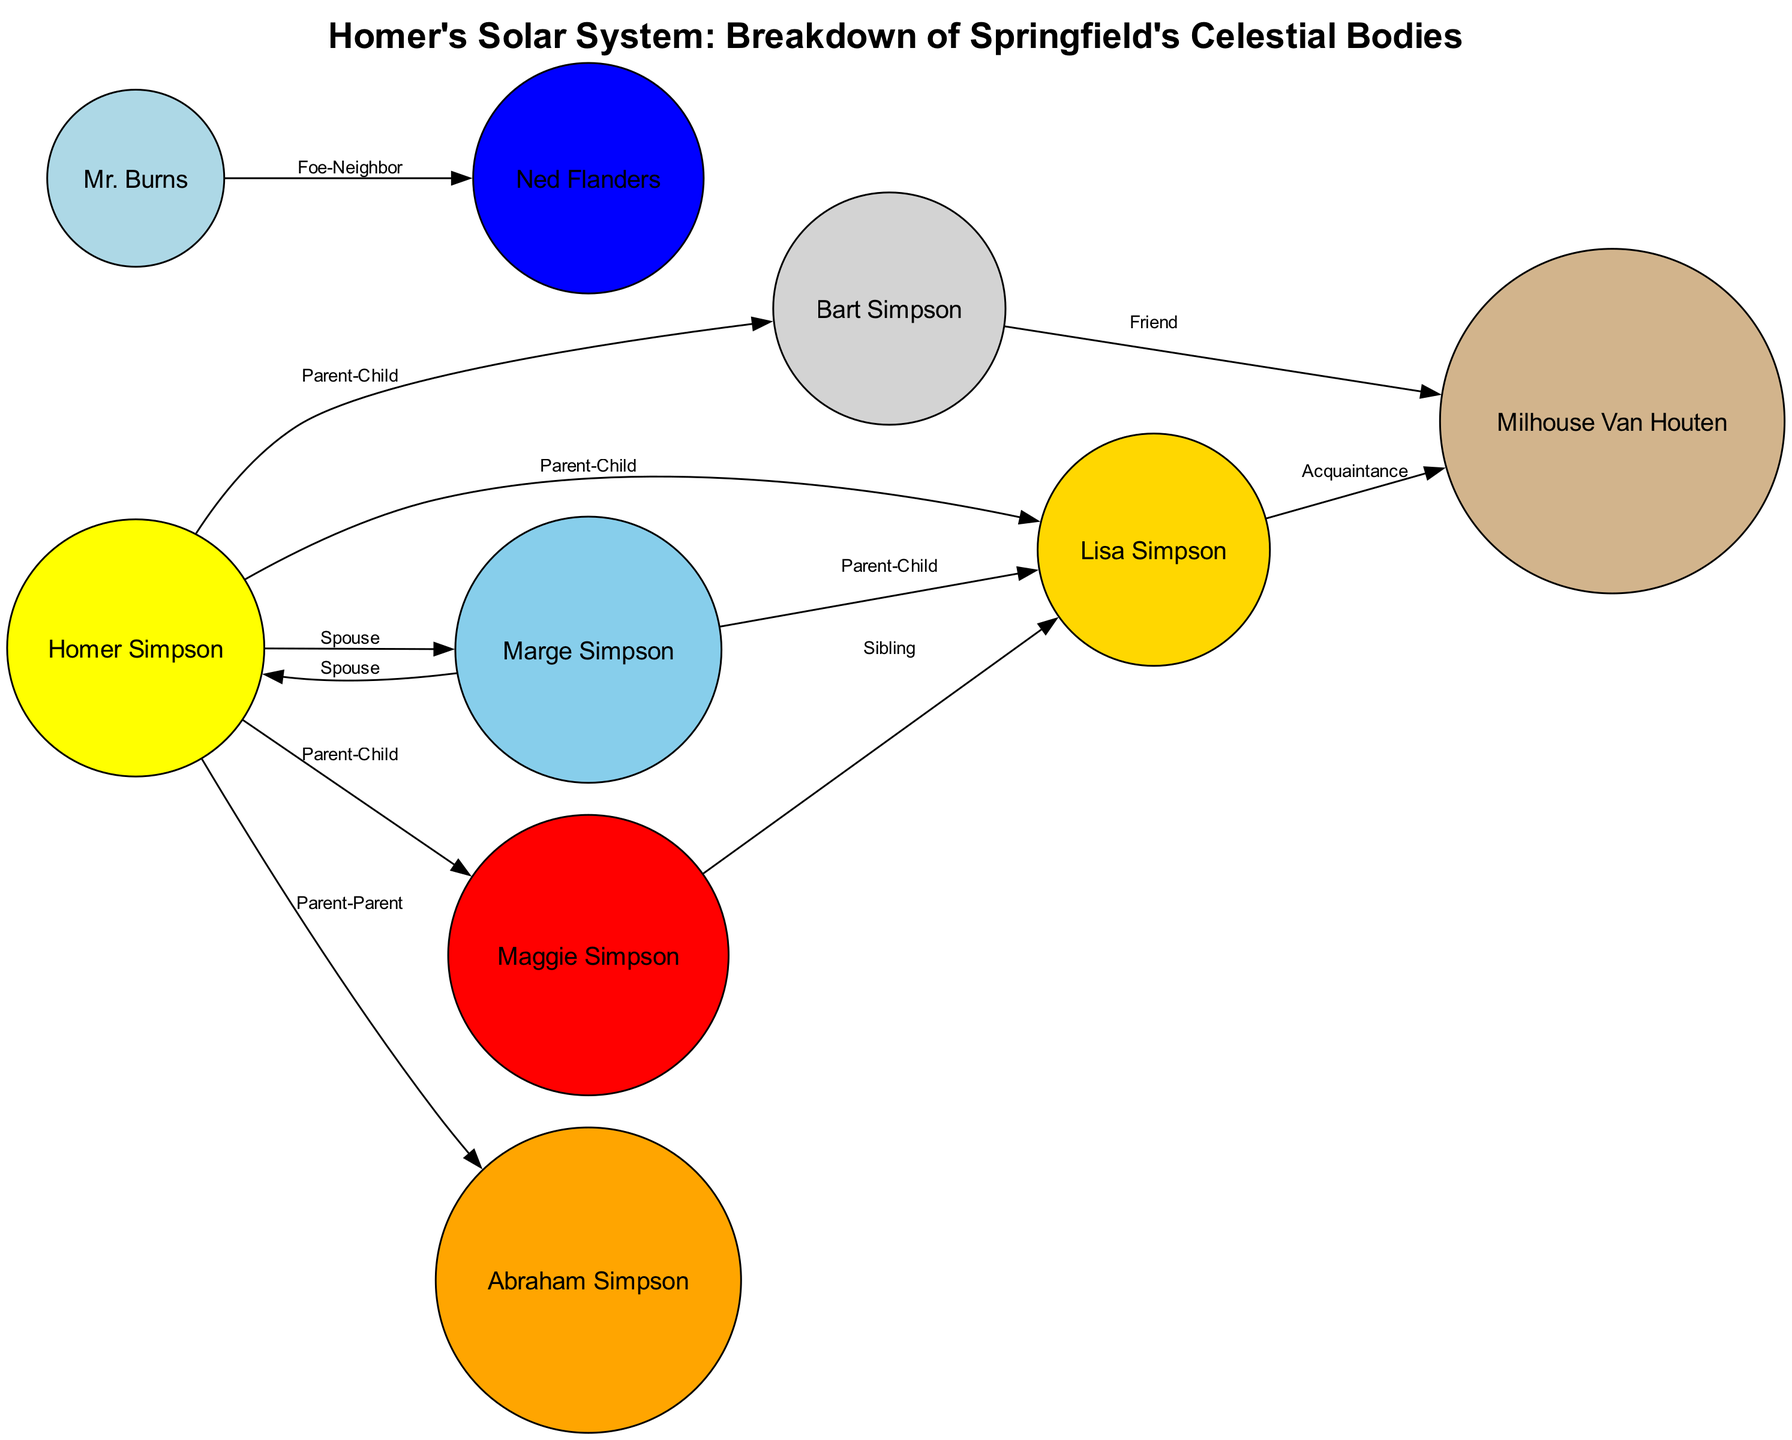What is the central star in the diagram? The diagram identifies "Homer Simpson" as the central star, which represents the heart and soul of 'The Simpsons'.
Answer: Homer Simpson Which character is represented as the planet Mars? In the diagram, Mars is represented by "Maggie Simpson," described as a small but powerful entity.
Answer: Maggie Simpson How many nodes are used to represent planets in this solar system? The diagram includes 8 nodes, comprising 7 planets and 1 star (Homer Simpson), to represent the characters.
Answer: 7 What type of relationship exists between Homer Simpson and Earth? The relationship between Homer Simpson and Earth is labeled as "Spouse," indicating a marital connection.
Answer: Spouse Who is depicted as the largest planet in the diagram? The diagram designates "Abraham Simpson" (Grandpa Simpson) as the largest planet, reflecting his abundance of stories and presence.
Answer: Abraham Simpson What complex relationship does Milhouse Van Houten have with other planets? Milhouse Van Houten (Saturn) has a "Friend" relationship with Bart (Mercury) and an "Acquaintance" relationship with Lisa (Venus), reflecting the various nature of friendships in the story.
Answer: Friend, Acquaintance Which two characters have a "Foe-Neighbor" relationship? The relationship is noted between "Mr. Burns" (Uranus) and "Ned Flanders" (Neptune), highlighting a contrasting dynamic between them.
Answer: Mr. Burns, Ned Flanders Name the character that represents the planet Venus. "Lisa Simpson" is the character depicted as Venus in the diagram, showcasing her intellect and brightness.
Answer: Lisa Simpson What celestial body has a relationship labeled as "Parent-Child" with both Mercury and Mars? "Homer Simpson" is shown as the central figure with a "Parent-Child" relationship to both the planets Mercury (Bart) and Mars (Maggie).
Answer: Homer Simpson 